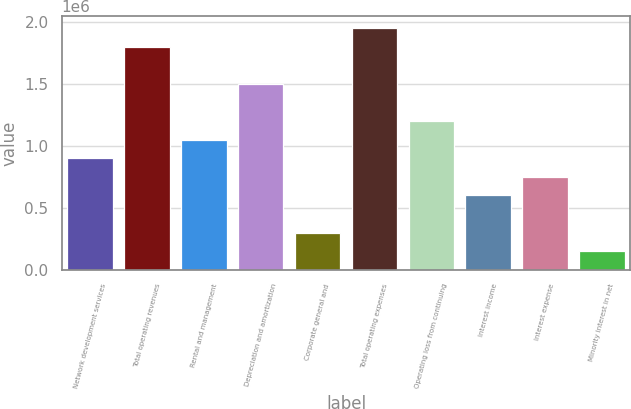Convert chart to OTSL. <chart><loc_0><loc_0><loc_500><loc_500><bar_chart><fcel>Network development services<fcel>Total operating revenues<fcel>Rental and management<fcel>Depreciation and amortization<fcel>Corporate general and<fcel>Total operating expenses<fcel>Operating loss from continuing<fcel>Interest income<fcel>Interest expense<fcel>Minority interest in net<nl><fcel>901406<fcel>1.80281e+06<fcel>1.05164e+06<fcel>1.50234e+06<fcel>300469<fcel>1.95305e+06<fcel>1.20187e+06<fcel>600937<fcel>751172<fcel>150235<nl></chart> 